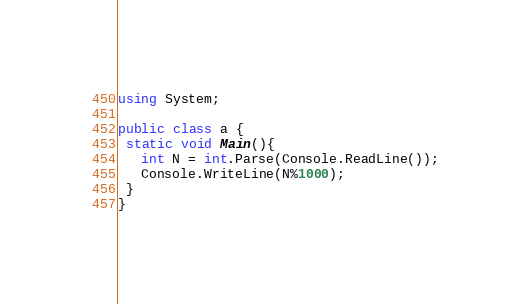Convert code to text. <code><loc_0><loc_0><loc_500><loc_500><_C#_>using System;

public class a {
 static void Main(){
   int N = int.Parse(Console.ReadLine());
   Console.WriteLine(N%1000);
 }
}
</code> 